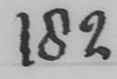Can you read and transcribe this handwriting? 182 